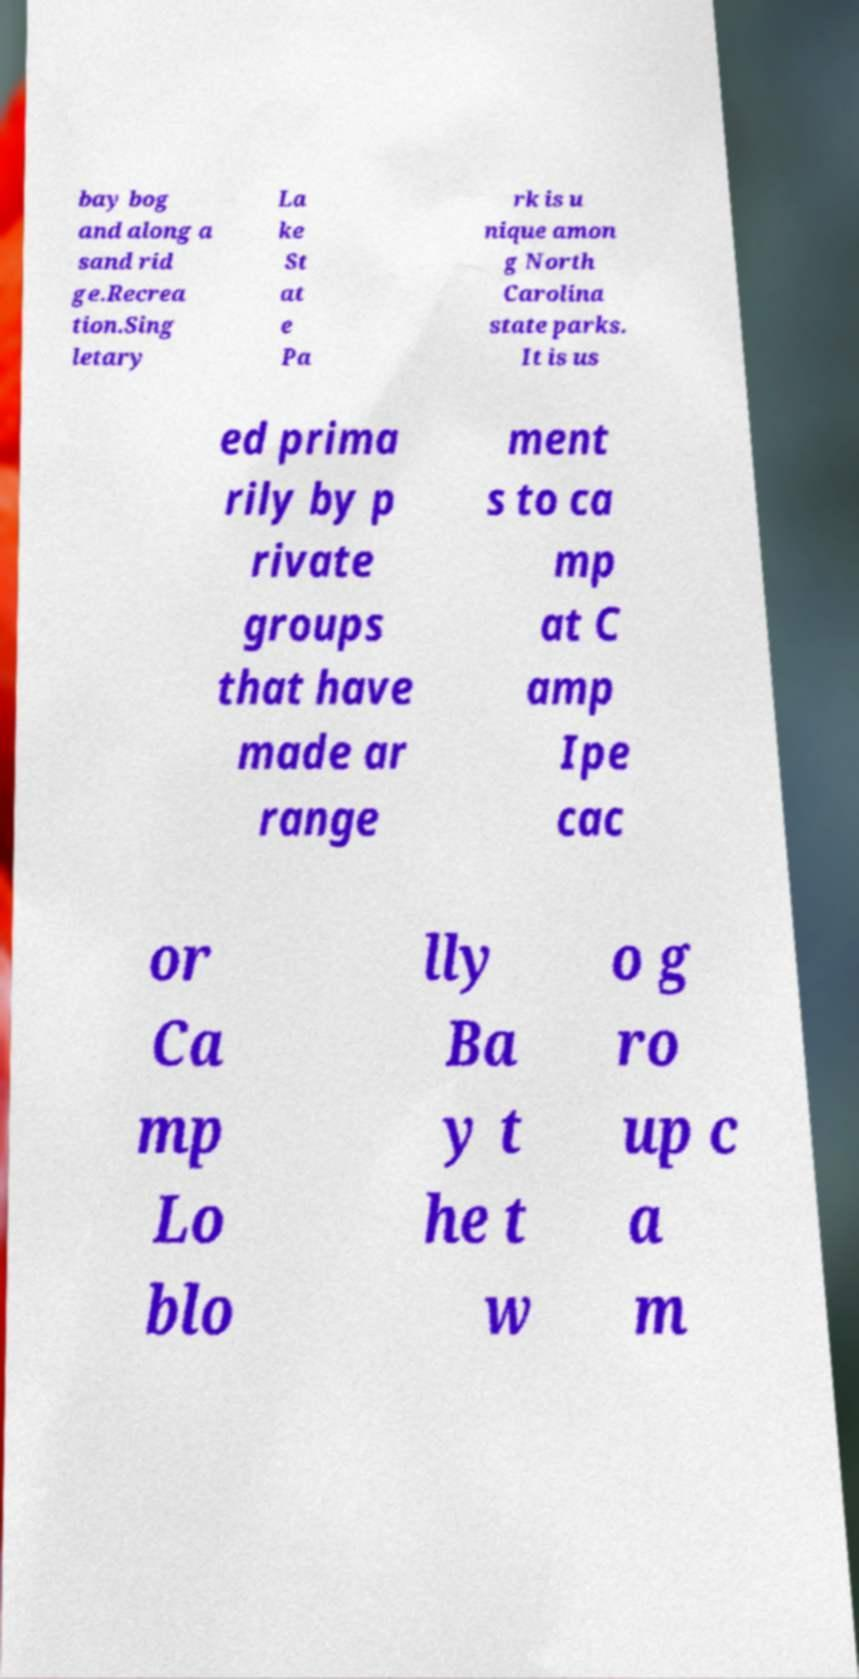What messages or text are displayed in this image? I need them in a readable, typed format. bay bog and along a sand rid ge.Recrea tion.Sing letary La ke St at e Pa rk is u nique amon g North Carolina state parks. It is us ed prima rily by p rivate groups that have made ar range ment s to ca mp at C amp Ipe cac or Ca mp Lo blo lly Ba y t he t w o g ro up c a m 